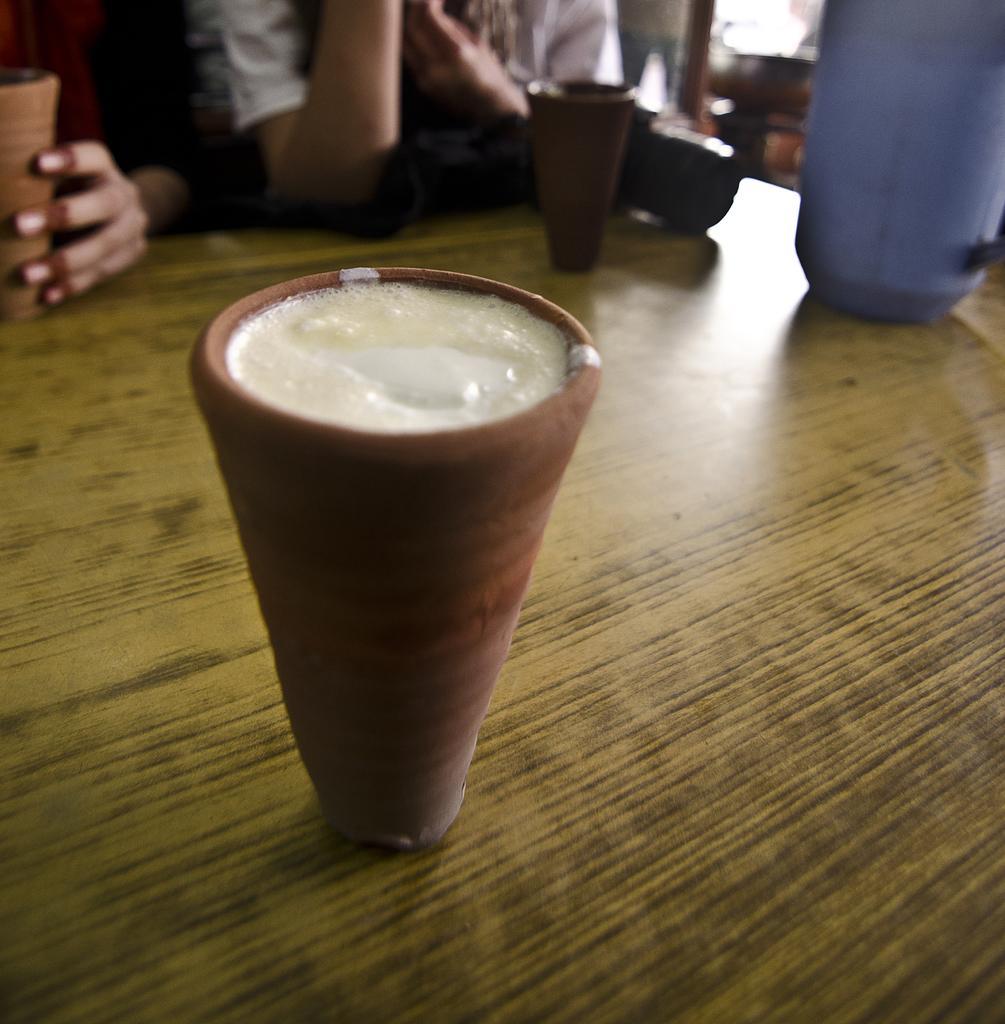Could you give a brief overview of what you see in this image? In front of the picture, we see the V-shaped clay glass containing the liquid is placed on the table. We see the blue color objects and clay glasses are placed on the table. Beside that, we see two people are sitting on the chairs. In the background, it is blurred. 